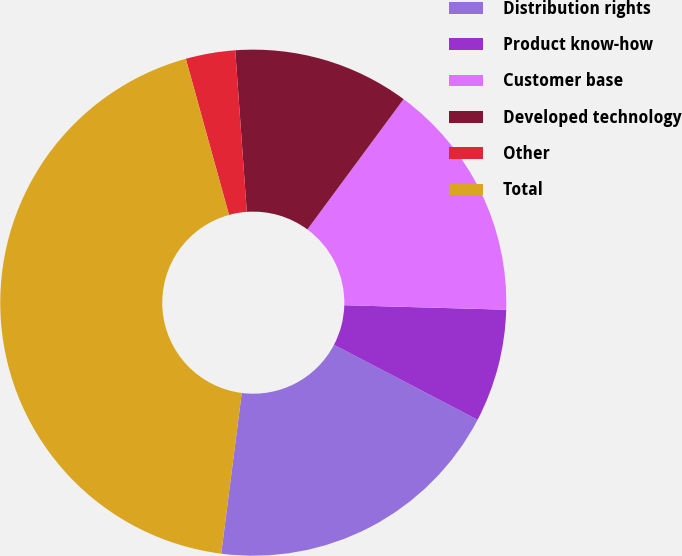Convert chart to OTSL. <chart><loc_0><loc_0><loc_500><loc_500><pie_chart><fcel>Distribution rights<fcel>Product know-how<fcel>Customer base<fcel>Developed technology<fcel>Other<fcel>Total<nl><fcel>19.37%<fcel>7.21%<fcel>15.32%<fcel>11.26%<fcel>3.16%<fcel>43.68%<nl></chart> 